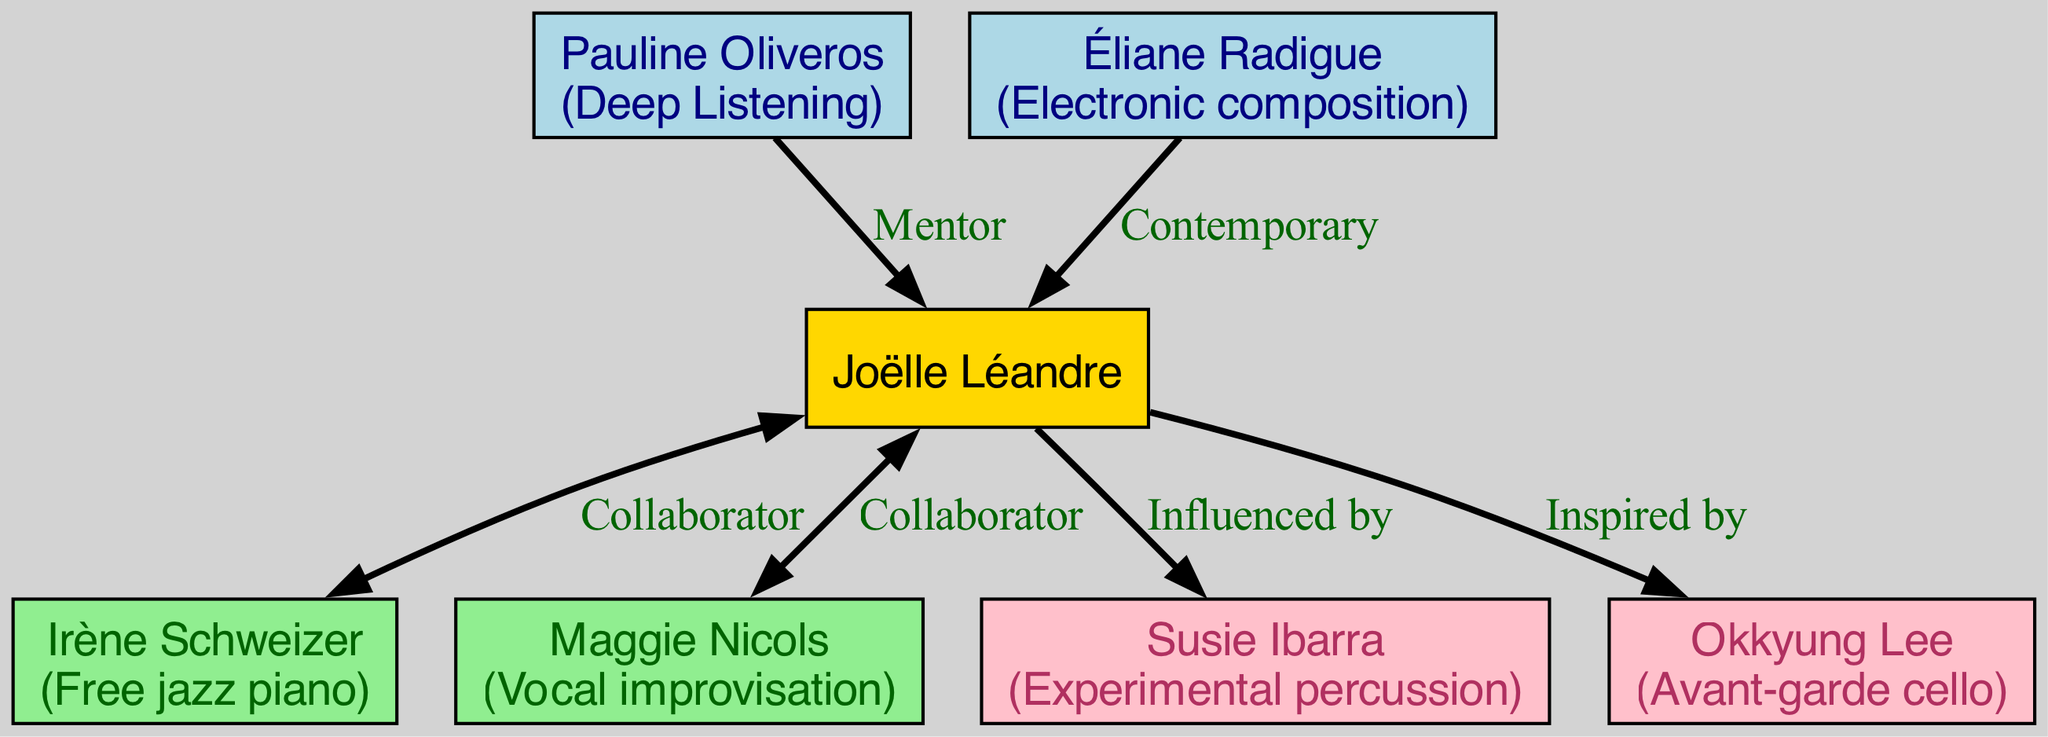What is Joëlle Léandre's primary role in the family tree? Joëlle Léandre is positioned at the root of the family tree, which signifies her primary role as a central figure connecting various predecessors, contemporaries, and successors in her lineage.
Answer: Central figure How many predecessors are shown in the diagram? The diagram displays two predecessors: Pauline Oliveros and Éliane Radigue. This count is based on the segment labeled "predecessors" directly connected to Joëlle Léandre.
Answer: 2 Who collaborated with Joëlle Léandre on free jazz piano? The collaborator identified in the diagram associated with free jazz piano is Irène Schweizer. This information is found in the contemporaries section linked to Joëlle Léandre.
Answer: Irène Schweizer What unique contribution does Okkyung Lee bring as a successor? Okkyung Lee is noted for her contribution of avant-garde cello. This contribution is listed under the successors section, showing her impact as someone influenced by Joëlle Léandre.
Answer: Avant-garde cello Who is listed as Joëlle Léandre's mentor and what was her contribution? Joëlle Léandre's mentor is Pauline Oliveros, and her contribution is deep listening. This information appears directly associated in the predecessors section of the family tree.
Answer: Pauline Oliveros, deep listening Which two individuals are shown as contemporaries of Joëlle Léandre? The contemporaries of Joëlle Léandre are Irène Schweizer and Maggie Nicols, both listed in the diagram as individuals collaborating with her around similar times.
Answer: Irène Schweizer, Maggie Nicols Name the relationship that connects Éliane Radigue to Joëlle Léandre. Éliane Radigue is connected as a contemporary to Joëlle Léandre, indicating they are of the same era in avant-garde music.
Answer: Contemporary Which color represents successors in the diagram? The color pink is used to represent successors in the diagram, specifically covering the nodes tied to Joëlle Léandre's influence.
Answer: Pink 